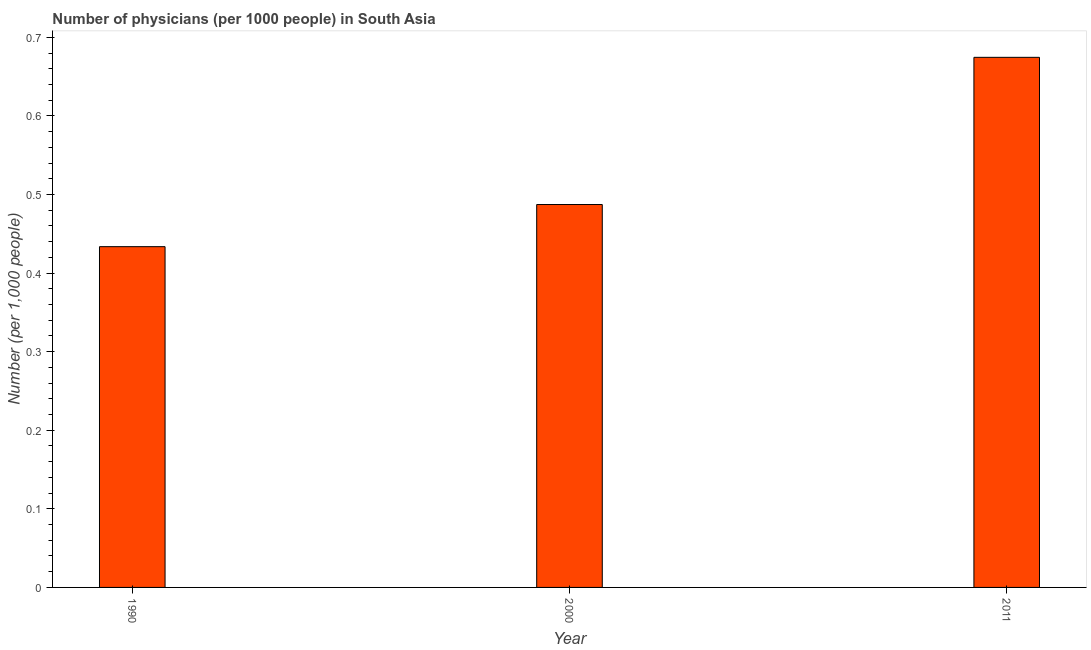What is the title of the graph?
Make the answer very short. Number of physicians (per 1000 people) in South Asia. What is the label or title of the Y-axis?
Ensure brevity in your answer.  Number (per 1,0 people). What is the number of physicians in 2011?
Make the answer very short. 0.67. Across all years, what is the maximum number of physicians?
Provide a short and direct response. 0.67. Across all years, what is the minimum number of physicians?
Offer a terse response. 0.43. In which year was the number of physicians maximum?
Give a very brief answer. 2011. What is the sum of the number of physicians?
Offer a very short reply. 1.6. What is the difference between the number of physicians in 2000 and 2011?
Provide a short and direct response. -0.19. What is the average number of physicians per year?
Offer a very short reply. 0.53. What is the median number of physicians?
Provide a short and direct response. 0.49. In how many years, is the number of physicians greater than 0.56 ?
Give a very brief answer. 1. Do a majority of the years between 1990 and 2000 (inclusive) have number of physicians greater than 0.12 ?
Your answer should be very brief. Yes. What is the ratio of the number of physicians in 2000 to that in 2011?
Ensure brevity in your answer.  0.72. Is the difference between the number of physicians in 1990 and 2011 greater than the difference between any two years?
Give a very brief answer. Yes. What is the difference between the highest and the second highest number of physicians?
Your answer should be very brief. 0.19. What is the difference between the highest and the lowest number of physicians?
Offer a terse response. 0.24. In how many years, is the number of physicians greater than the average number of physicians taken over all years?
Provide a succinct answer. 1. Are all the bars in the graph horizontal?
Provide a short and direct response. No. How many years are there in the graph?
Offer a terse response. 3. Are the values on the major ticks of Y-axis written in scientific E-notation?
Your answer should be very brief. No. What is the Number (per 1,000 people) of 1990?
Your response must be concise. 0.43. What is the Number (per 1,000 people) in 2000?
Keep it short and to the point. 0.49. What is the Number (per 1,000 people) in 2011?
Give a very brief answer. 0.67. What is the difference between the Number (per 1,000 people) in 1990 and 2000?
Provide a succinct answer. -0.05. What is the difference between the Number (per 1,000 people) in 1990 and 2011?
Offer a terse response. -0.24. What is the difference between the Number (per 1,000 people) in 2000 and 2011?
Give a very brief answer. -0.19. What is the ratio of the Number (per 1,000 people) in 1990 to that in 2000?
Keep it short and to the point. 0.89. What is the ratio of the Number (per 1,000 people) in 1990 to that in 2011?
Give a very brief answer. 0.64. What is the ratio of the Number (per 1,000 people) in 2000 to that in 2011?
Keep it short and to the point. 0.72. 